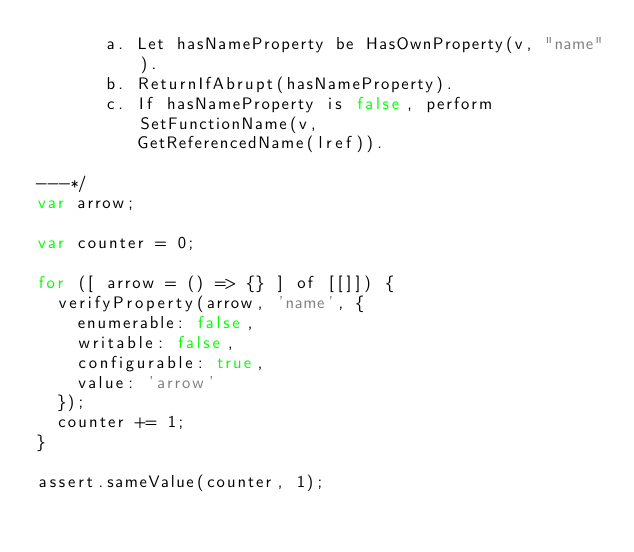<code> <loc_0><loc_0><loc_500><loc_500><_JavaScript_>       a. Let hasNameProperty be HasOwnProperty(v, "name").
       b. ReturnIfAbrupt(hasNameProperty).
       c. If hasNameProperty is false, perform SetFunctionName(v,
          GetReferencedName(lref)).

---*/
var arrow;

var counter = 0;

for ([ arrow = () => {} ] of [[]]) {
  verifyProperty(arrow, 'name', {
    enumerable: false,
    writable: false,
    configurable: true,
    value: 'arrow'
  });
  counter += 1;
}

assert.sameValue(counter, 1);
</code> 